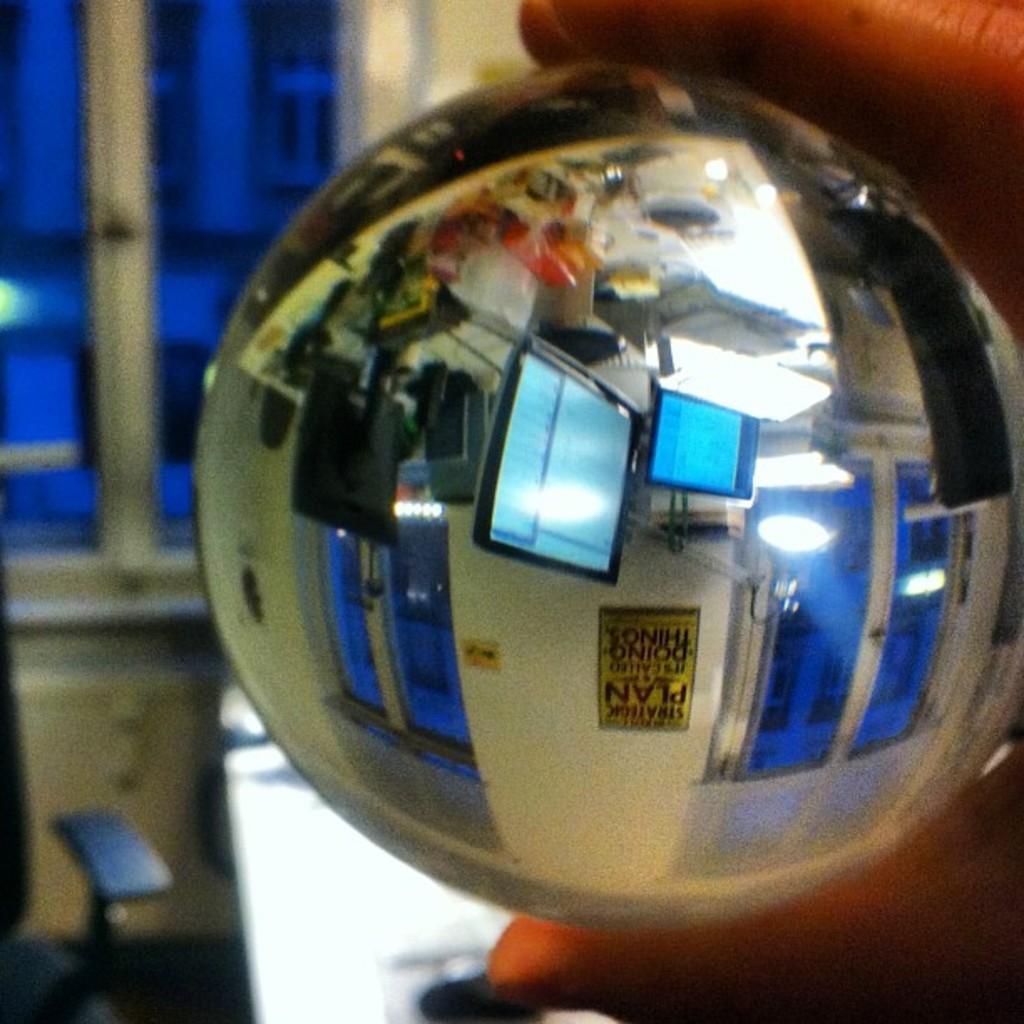Please provide a concise description of this image. In this picture we can see a person's hand is holding a ball and we can see the reflection of monitors, wall, windows and some objects and in the background we can see some objects. 